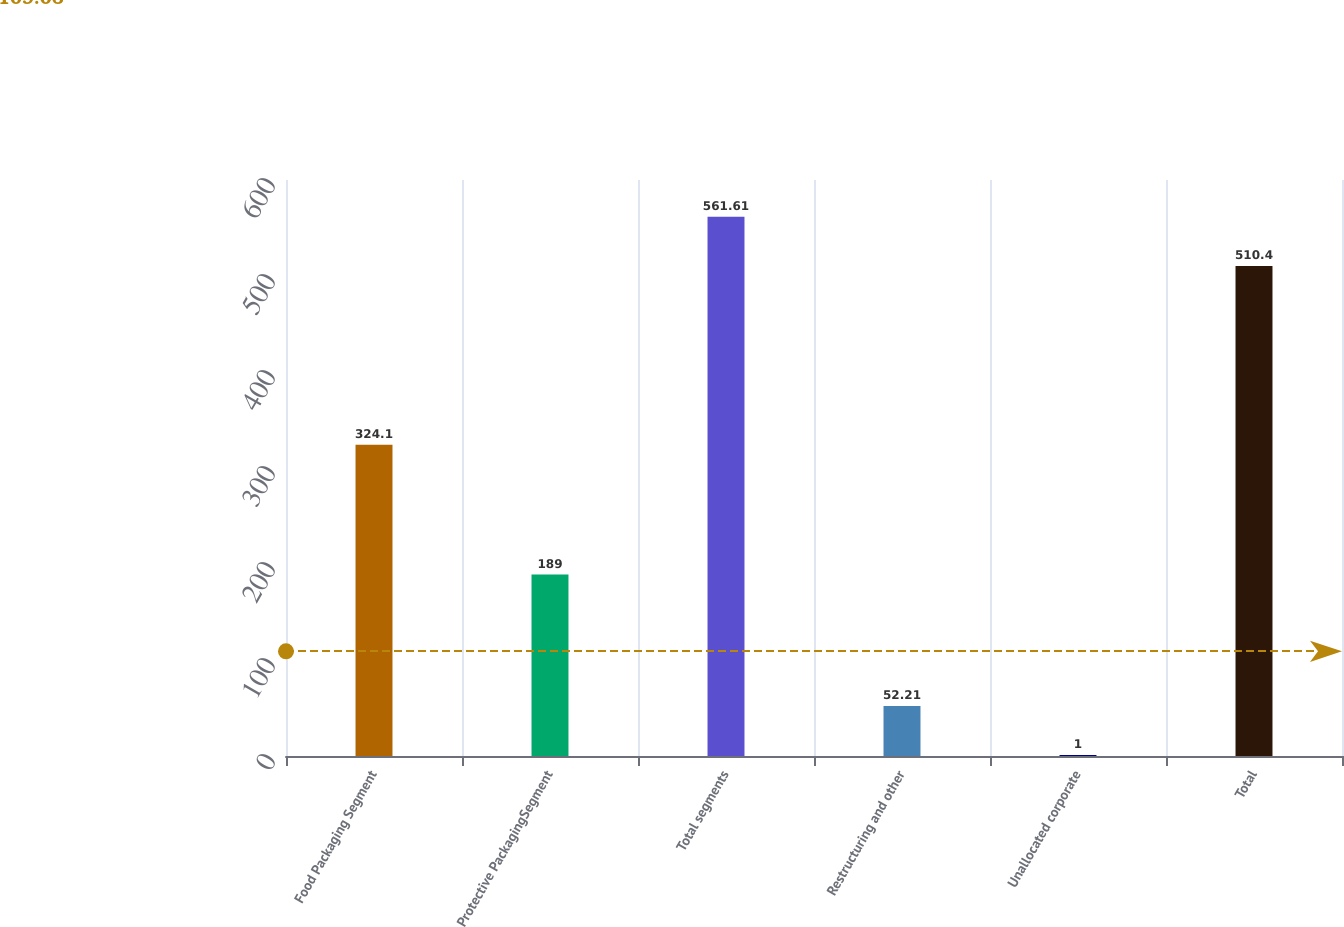Convert chart. <chart><loc_0><loc_0><loc_500><loc_500><bar_chart><fcel>Food Packaging Segment<fcel>Protective PackagingSegment<fcel>Total segments<fcel>Restructuring and other<fcel>Unallocated corporate<fcel>Total<nl><fcel>324.1<fcel>189<fcel>561.61<fcel>52.21<fcel>1<fcel>510.4<nl></chart> 